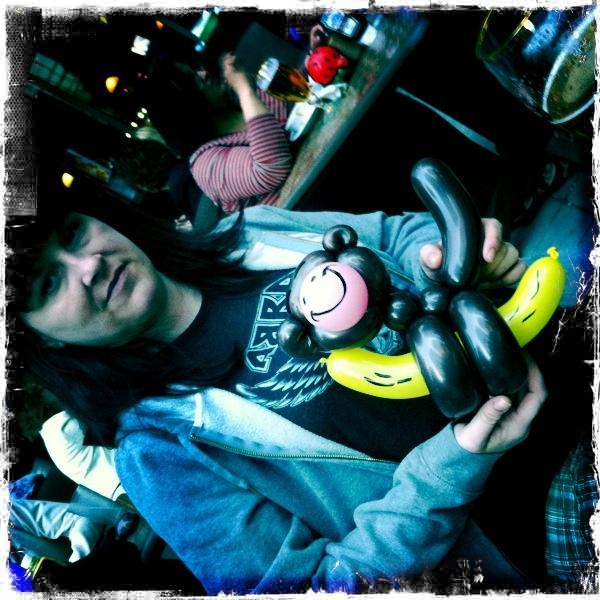What is the color of the monkey?
Quick response, please. Black. What is this womans balloon shaped like?
Short answer required. Monkey. Is the woman's mouth open or closed?
Be succinct. Closed. 